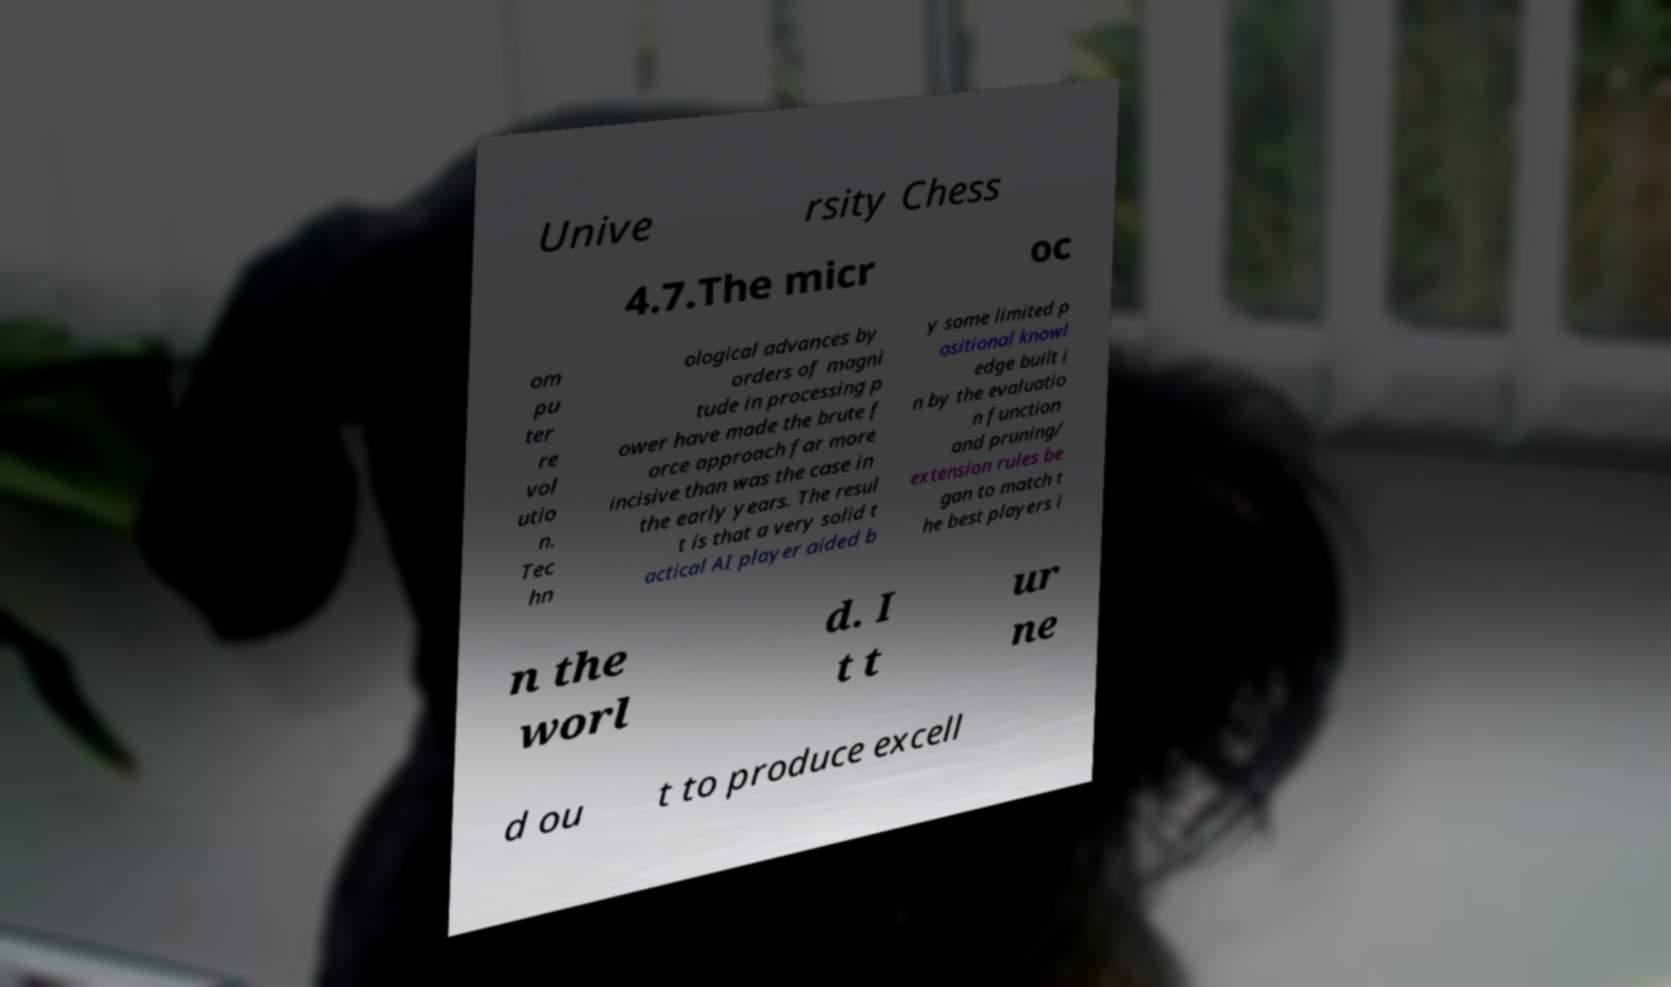What messages or text are displayed in this image? I need them in a readable, typed format. Unive rsity Chess 4.7.The micr oc om pu ter re vol utio n. Tec hn ological advances by orders of magni tude in processing p ower have made the brute f orce approach far more incisive than was the case in the early years. The resul t is that a very solid t actical AI player aided b y some limited p ositional knowl edge built i n by the evaluatio n function and pruning/ extension rules be gan to match t he best players i n the worl d. I t t ur ne d ou t to produce excell 